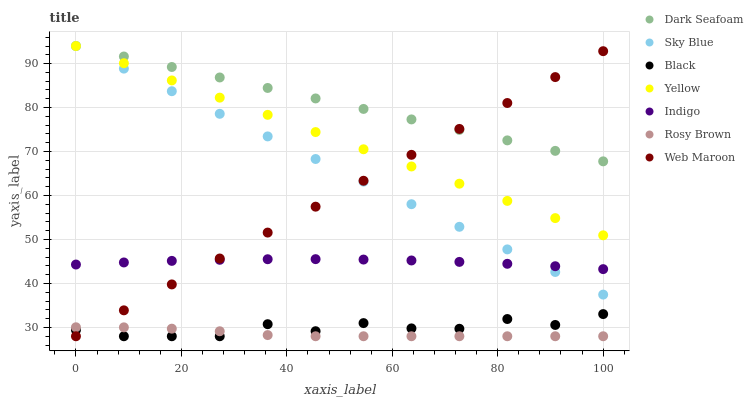Does Rosy Brown have the minimum area under the curve?
Answer yes or no. Yes. Does Dark Seafoam have the maximum area under the curve?
Answer yes or no. Yes. Does Web Maroon have the minimum area under the curve?
Answer yes or no. No. Does Web Maroon have the maximum area under the curve?
Answer yes or no. No. Is Web Maroon the smoothest?
Answer yes or no. Yes. Is Black the roughest?
Answer yes or no. Yes. Is Rosy Brown the smoothest?
Answer yes or no. No. Is Rosy Brown the roughest?
Answer yes or no. No. Does Rosy Brown have the lowest value?
Answer yes or no. Yes. Does Yellow have the lowest value?
Answer yes or no. No. Does Sky Blue have the highest value?
Answer yes or no. Yes. Does Web Maroon have the highest value?
Answer yes or no. No. Is Black less than Dark Seafoam?
Answer yes or no. Yes. Is Sky Blue greater than Black?
Answer yes or no. Yes. Does Rosy Brown intersect Black?
Answer yes or no. Yes. Is Rosy Brown less than Black?
Answer yes or no. No. Is Rosy Brown greater than Black?
Answer yes or no. No. Does Black intersect Dark Seafoam?
Answer yes or no. No. 